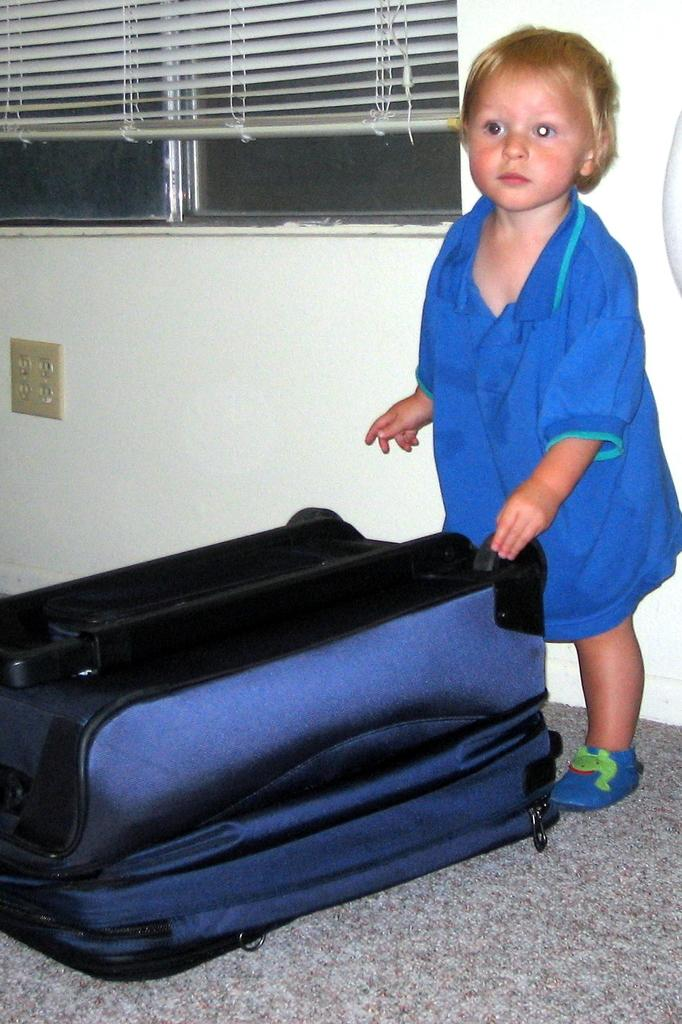What is the main subject of the image? There is a child in the image. What is the child wearing? The child is wearing a blue t-shirt. Where is the child standing? The child is standing on the floor. What is in front of the child? There is a bag in front of the child. What can be seen in the background of the image? There are window blinds in the background of the image. What type of dinner is being prepared in the image? There is no indication of dinner preparation in the image; it primarily features a child standing on the floor with a bag in front of them. 